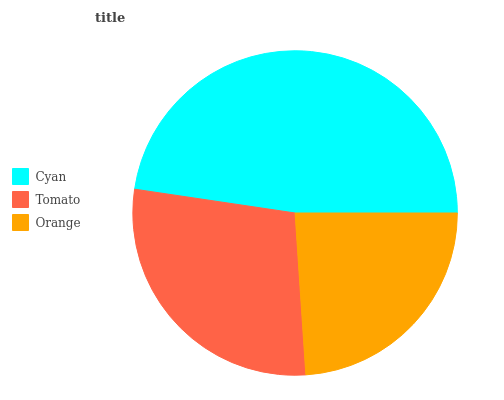Is Orange the minimum?
Answer yes or no. Yes. Is Cyan the maximum?
Answer yes or no. Yes. Is Tomato the minimum?
Answer yes or no. No. Is Tomato the maximum?
Answer yes or no. No. Is Cyan greater than Tomato?
Answer yes or no. Yes. Is Tomato less than Cyan?
Answer yes or no. Yes. Is Tomato greater than Cyan?
Answer yes or no. No. Is Cyan less than Tomato?
Answer yes or no. No. Is Tomato the high median?
Answer yes or no. Yes. Is Tomato the low median?
Answer yes or no. Yes. Is Orange the high median?
Answer yes or no. No. Is Orange the low median?
Answer yes or no. No. 